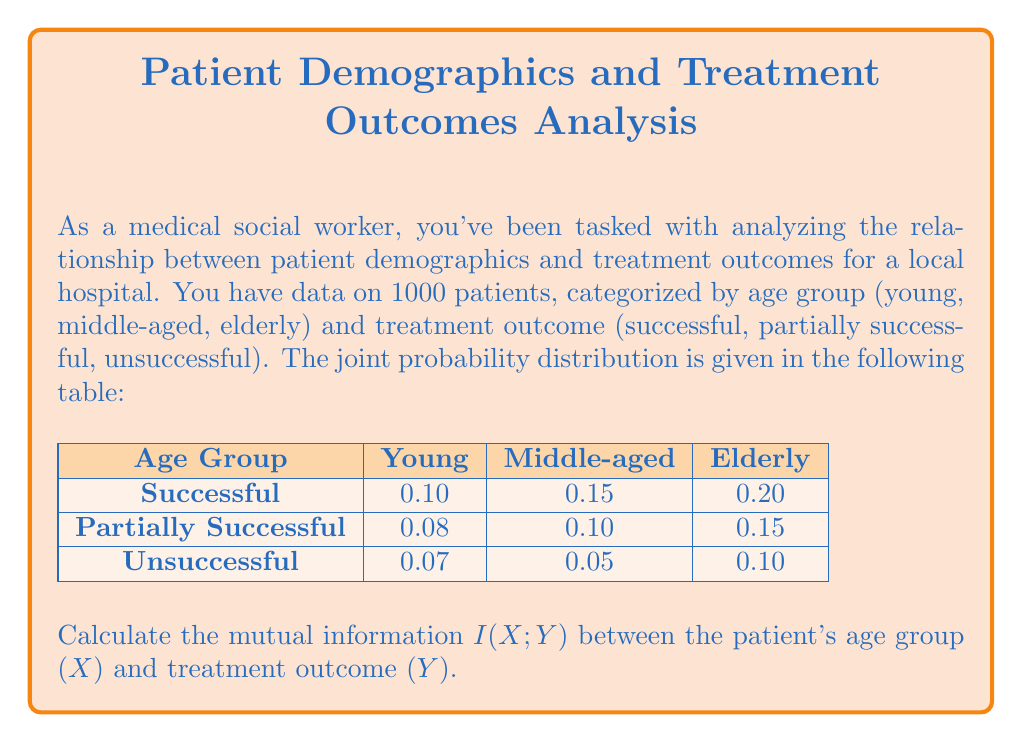Can you answer this question? To calculate the mutual information $I(X;Y)$, we'll follow these steps:

1) First, we need to calculate the marginal probabilities for X and Y:

   $P(X = \text{young}) = 0.10 + 0.08 + 0.07 = 0.25$
   $P(X = \text{middle-aged}) = 0.15 + 0.10 + 0.05 = 0.30$
   $P(X = \text{elderly}) = 0.20 + 0.15 + 0.10 = 0.45$

   $P(Y = \text{successful}) = 0.10 + 0.15 + 0.20 = 0.45$
   $P(Y = \text{partially successful}) = 0.08 + 0.10 + 0.15 = 0.33$
   $P(Y = \text{unsuccessful}) = 0.07 + 0.05 + 0.10 = 0.22$

2) The mutual information is defined as:

   $$I(X;Y) = \sum_{x \in X} \sum_{y \in Y} P(x,y) \log_2 \frac{P(x,y)}{P(x)P(y)}$$

3) Let's calculate each term:

   $0.10 \log_2 \frac{0.10}{0.25 \cdot 0.45} = 0.0365$
   $0.15 \log_2 \frac{0.15}{0.30 \cdot 0.45} = 0.0458$
   $0.20 \log_2 \frac{0.20}{0.45 \cdot 0.45} = 0.0146$
   $0.08 \log_2 \frac{0.08}{0.25 \cdot 0.33} = 0.0305$
   $0.10 \log_2 \frac{0.10}{0.30 \cdot 0.33} = 0.0305$
   $0.15 \log_2 \frac{0.15}{0.45 \cdot 0.33} = 0.0305$
   $0.07 \log_2 \frac{0.07}{0.25 \cdot 0.22} = 0.0305$
   $0.05 \log_2 \frac{0.05}{0.30 \cdot 0.22} = 0.0012$
   $0.10 \log_2 \frac{0.10}{0.45 \cdot 0.22} = 0.0305$

4) Sum all these terms:

   $I(X;Y) = 0.0365 + 0.0458 + 0.0146 + 0.0305 + 0.0305 + 0.0305 + 0.0305 + 0.0012 + 0.0305 = 0.2506$

Therefore, the mutual information $I(X;Y)$ is approximately 0.2506 bits.
Answer: $I(X;Y) \approx 0.2506$ bits 